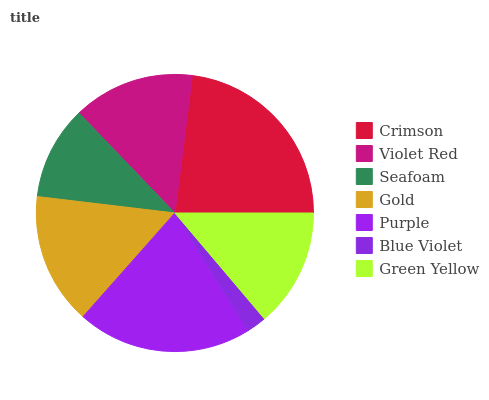Is Blue Violet the minimum?
Answer yes or no. Yes. Is Crimson the maximum?
Answer yes or no. Yes. Is Violet Red the minimum?
Answer yes or no. No. Is Violet Red the maximum?
Answer yes or no. No. Is Crimson greater than Violet Red?
Answer yes or no. Yes. Is Violet Red less than Crimson?
Answer yes or no. Yes. Is Violet Red greater than Crimson?
Answer yes or no. No. Is Crimson less than Violet Red?
Answer yes or no. No. Is Violet Red the high median?
Answer yes or no. Yes. Is Violet Red the low median?
Answer yes or no. Yes. Is Green Yellow the high median?
Answer yes or no. No. Is Green Yellow the low median?
Answer yes or no. No. 